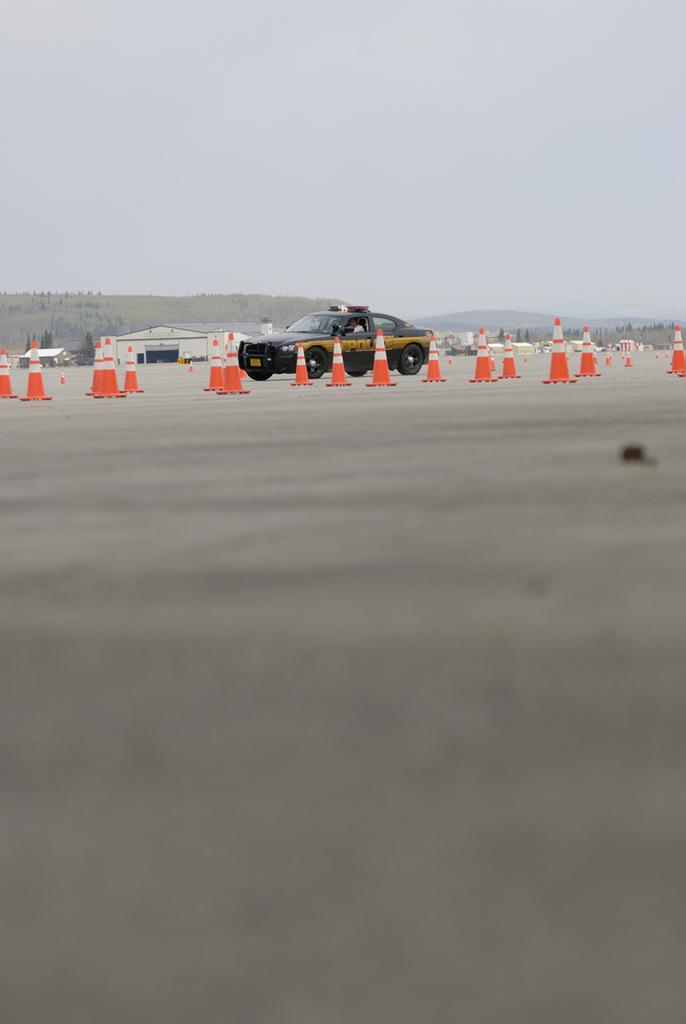What is the most prominent feature in the image? There are many traffic cones in the image. What type of vehicle can be seen in the image? There is a black car in the image. What can be seen in the distance in the image? Hills are visible in the background of the image. What is visible above the hills in the image? The sky is visible in the background of the image. What is the current price of the traffic cones in the image? The image does not provide information about the price of the traffic cones. --- 